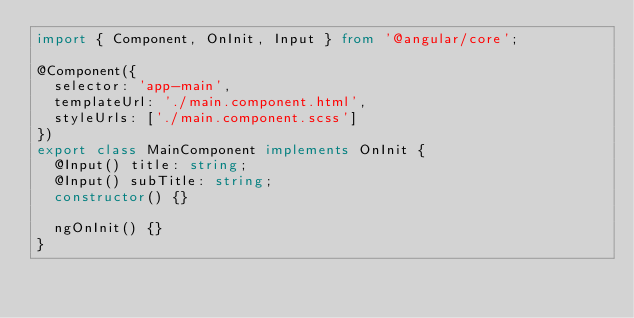<code> <loc_0><loc_0><loc_500><loc_500><_TypeScript_>import { Component, OnInit, Input } from '@angular/core';

@Component({
  selector: 'app-main',
  templateUrl: './main.component.html',
  styleUrls: ['./main.component.scss']
})
export class MainComponent implements OnInit {
  @Input() title: string;
  @Input() subTitle: string;
  constructor() {}

  ngOnInit() {}
}
</code> 